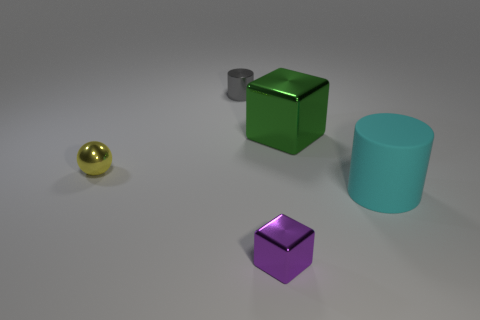Subtract all blocks. How many objects are left? 3 Add 1 yellow metallic balls. How many yellow metallic balls exist? 2 Add 4 large things. How many objects exist? 9 Subtract 1 green blocks. How many objects are left? 4 Subtract 1 cubes. How many cubes are left? 1 Subtract all purple cylinders. Subtract all green cubes. How many cylinders are left? 2 Subtract all green cylinders. How many green blocks are left? 1 Subtract all small purple things. Subtract all big green metal blocks. How many objects are left? 3 Add 1 cyan matte cylinders. How many cyan matte cylinders are left? 2 